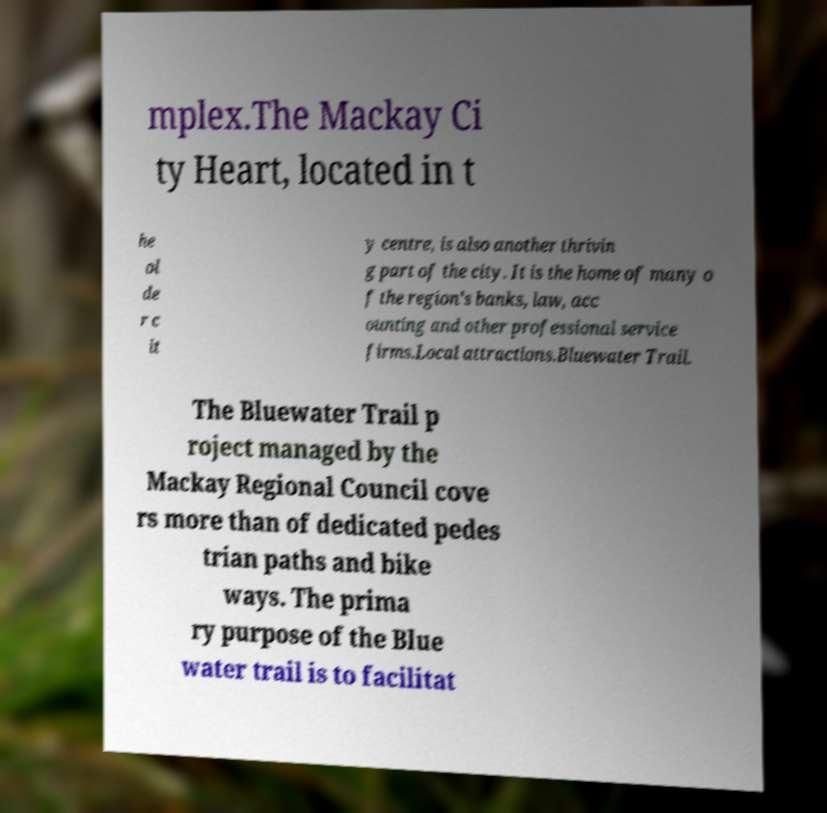What messages or text are displayed in this image? I need them in a readable, typed format. mplex.The Mackay Ci ty Heart, located in t he ol de r c it y centre, is also another thrivin g part of the city. It is the home of many o f the region's banks, law, acc ounting and other professional service firms.Local attractions.Bluewater Trail. The Bluewater Trail p roject managed by the Mackay Regional Council cove rs more than of dedicated pedes trian paths and bike ways. The prima ry purpose of the Blue water trail is to facilitat 